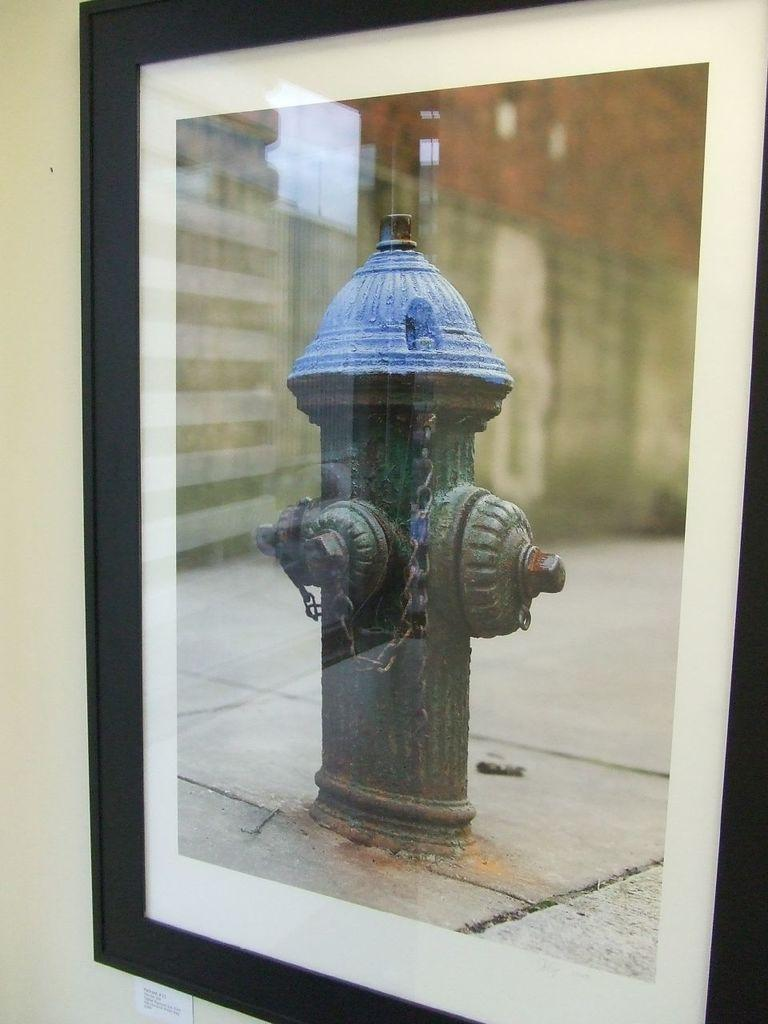What is hanging on the wall in the image? There is a photo-frame on the wall in the image. What is depicted in the photo-frame? The photo-frame contains an image of a fire hydrant and a building. Where can the worm be seen in the wilderness in the image? There is no worm or wilderness present in the image; it features a photo-frame with an image of a fire hydrant and a building. 